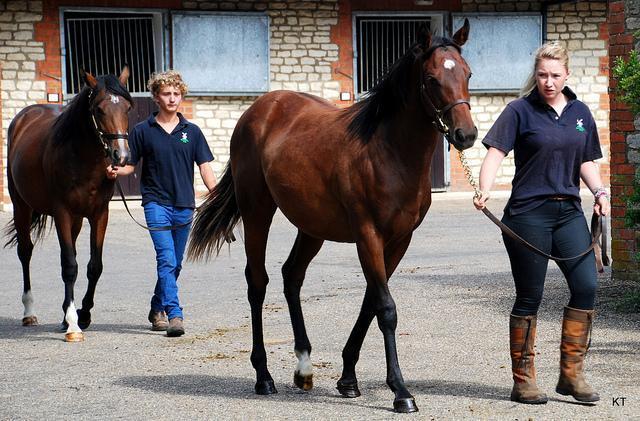How many horses are there?
Give a very brief answer. 2. How many people are there?
Give a very brief answer. 2. How many horses are looking at the camera?
Give a very brief answer. 0. How many horses can you see?
Give a very brief answer. 2. How many people are in the picture?
Give a very brief answer. 2. 